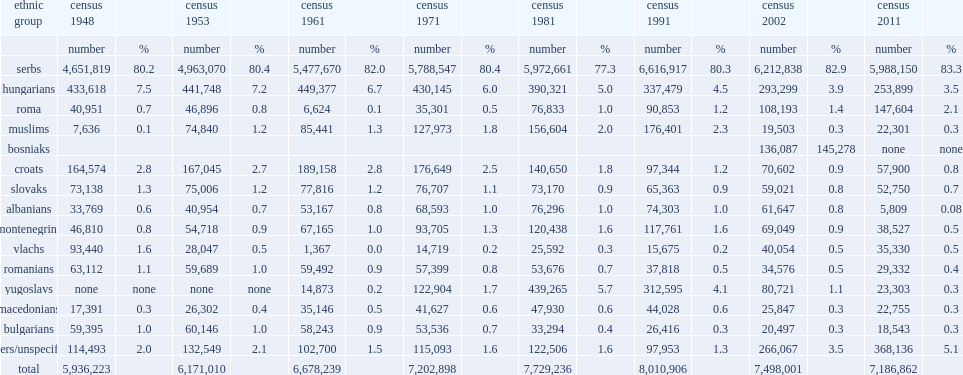What was the population percentage of serbs according to the 2011 census? 83.3. 